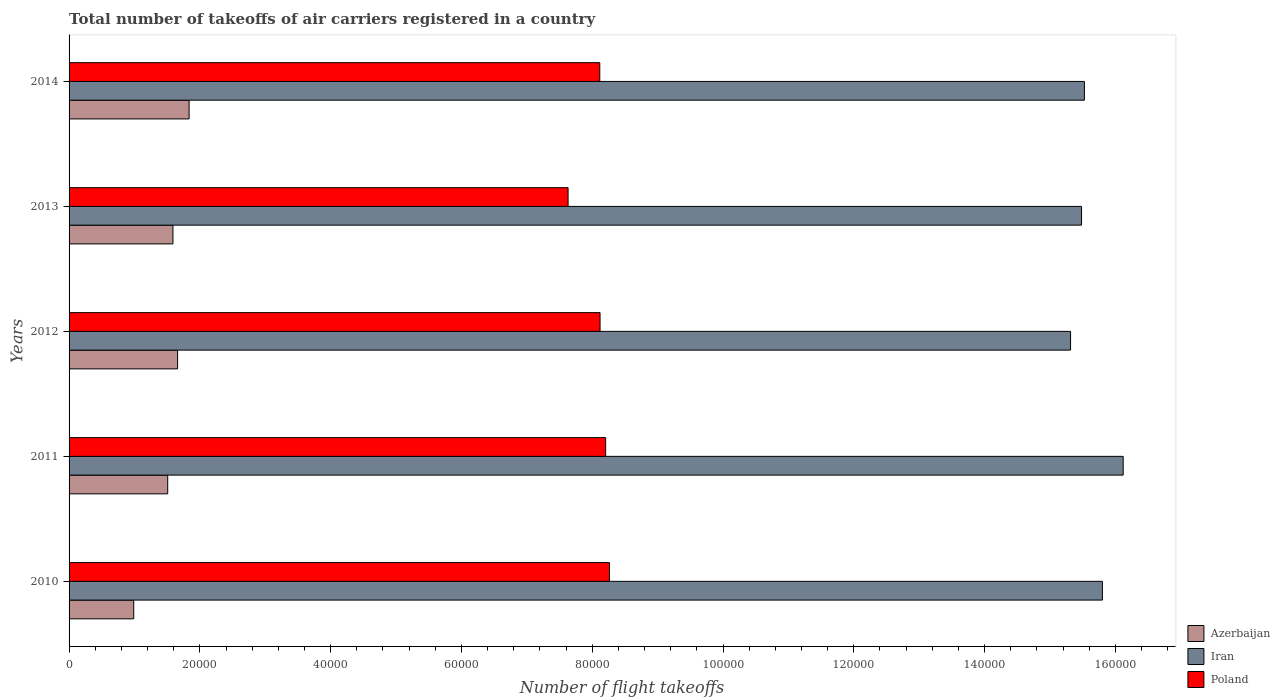In how many cases, is the number of bars for a given year not equal to the number of legend labels?
Offer a very short reply. 0. What is the total number of flight takeoffs in Iran in 2012?
Offer a very short reply. 1.53e+05. Across all years, what is the maximum total number of flight takeoffs in Iran?
Offer a terse response. 1.61e+05. Across all years, what is the minimum total number of flight takeoffs in Iran?
Ensure brevity in your answer.  1.53e+05. In which year was the total number of flight takeoffs in Iran maximum?
Give a very brief answer. 2011. What is the total total number of flight takeoffs in Poland in the graph?
Provide a short and direct response. 4.03e+05. What is the difference between the total number of flight takeoffs in Poland in 2010 and that in 2013?
Provide a short and direct response. 6324. What is the difference between the total number of flight takeoffs in Poland in 2010 and the total number of flight takeoffs in Iran in 2011?
Your answer should be compact. -7.86e+04. What is the average total number of flight takeoffs in Azerbaijan per year?
Offer a terse response. 1.52e+04. In the year 2011, what is the difference between the total number of flight takeoffs in Iran and total number of flight takeoffs in Azerbaijan?
Provide a short and direct response. 1.46e+05. In how many years, is the total number of flight takeoffs in Poland greater than 136000 ?
Ensure brevity in your answer.  0. What is the ratio of the total number of flight takeoffs in Azerbaijan in 2012 to that in 2013?
Your answer should be compact. 1.04. Is the difference between the total number of flight takeoffs in Iran in 2012 and 2013 greater than the difference between the total number of flight takeoffs in Azerbaijan in 2012 and 2013?
Ensure brevity in your answer.  No. What is the difference between the highest and the second highest total number of flight takeoffs in Poland?
Offer a very short reply. 578. What is the difference between the highest and the lowest total number of flight takeoffs in Iran?
Offer a terse response. 8048.86. In how many years, is the total number of flight takeoffs in Poland greater than the average total number of flight takeoffs in Poland taken over all years?
Your answer should be compact. 4. Is the sum of the total number of flight takeoffs in Poland in 2010 and 2012 greater than the maximum total number of flight takeoffs in Azerbaijan across all years?
Your response must be concise. Yes. What does the 3rd bar from the top in 2010 represents?
Give a very brief answer. Azerbaijan. What does the 2nd bar from the bottom in 2012 represents?
Provide a short and direct response. Iran. Is it the case that in every year, the sum of the total number of flight takeoffs in Azerbaijan and total number of flight takeoffs in Poland is greater than the total number of flight takeoffs in Iran?
Offer a very short reply. No. How many years are there in the graph?
Provide a succinct answer. 5. Are the values on the major ticks of X-axis written in scientific E-notation?
Provide a short and direct response. No. Does the graph contain any zero values?
Your answer should be compact. No. Where does the legend appear in the graph?
Your response must be concise. Bottom right. How are the legend labels stacked?
Make the answer very short. Vertical. What is the title of the graph?
Keep it short and to the point. Total number of takeoffs of air carriers registered in a country. Does "European Union" appear as one of the legend labels in the graph?
Offer a very short reply. No. What is the label or title of the X-axis?
Provide a succinct answer. Number of flight takeoffs. What is the label or title of the Y-axis?
Make the answer very short. Years. What is the Number of flight takeoffs of Azerbaijan in 2010?
Provide a succinct answer. 9885. What is the Number of flight takeoffs in Iran in 2010?
Your answer should be compact. 1.58e+05. What is the Number of flight takeoffs in Poland in 2010?
Provide a succinct answer. 8.26e+04. What is the Number of flight takeoffs of Azerbaijan in 2011?
Offer a very short reply. 1.51e+04. What is the Number of flight takeoffs of Iran in 2011?
Keep it short and to the point. 1.61e+05. What is the Number of flight takeoffs of Poland in 2011?
Provide a succinct answer. 8.21e+04. What is the Number of flight takeoffs in Azerbaijan in 2012?
Your answer should be very brief. 1.66e+04. What is the Number of flight takeoffs of Iran in 2012?
Offer a terse response. 1.53e+05. What is the Number of flight takeoffs in Poland in 2012?
Offer a terse response. 8.12e+04. What is the Number of flight takeoffs in Azerbaijan in 2013?
Make the answer very short. 1.59e+04. What is the Number of flight takeoffs in Iran in 2013?
Your answer should be very brief. 1.55e+05. What is the Number of flight takeoffs in Poland in 2013?
Your answer should be compact. 7.63e+04. What is the Number of flight takeoffs in Azerbaijan in 2014?
Make the answer very short. 1.84e+04. What is the Number of flight takeoffs of Iran in 2014?
Your answer should be compact. 1.55e+05. What is the Number of flight takeoffs of Poland in 2014?
Make the answer very short. 8.12e+04. Across all years, what is the maximum Number of flight takeoffs in Azerbaijan?
Your answer should be compact. 1.84e+04. Across all years, what is the maximum Number of flight takeoffs in Iran?
Your response must be concise. 1.61e+05. Across all years, what is the maximum Number of flight takeoffs of Poland?
Provide a succinct answer. 8.26e+04. Across all years, what is the minimum Number of flight takeoffs in Azerbaijan?
Give a very brief answer. 9885. Across all years, what is the minimum Number of flight takeoffs in Iran?
Offer a very short reply. 1.53e+05. Across all years, what is the minimum Number of flight takeoffs in Poland?
Keep it short and to the point. 7.63e+04. What is the total Number of flight takeoffs in Azerbaijan in the graph?
Provide a short and direct response. 7.58e+04. What is the total Number of flight takeoffs of Iran in the graph?
Offer a very short reply. 7.82e+05. What is the total Number of flight takeoffs of Poland in the graph?
Provide a succinct answer. 4.03e+05. What is the difference between the Number of flight takeoffs of Azerbaijan in 2010 and that in 2011?
Offer a very short reply. -5197. What is the difference between the Number of flight takeoffs in Iran in 2010 and that in 2011?
Your answer should be very brief. -3177.49. What is the difference between the Number of flight takeoffs of Poland in 2010 and that in 2011?
Make the answer very short. 578. What is the difference between the Number of flight takeoffs in Azerbaijan in 2010 and that in 2012?
Make the answer very short. -6712. What is the difference between the Number of flight takeoffs of Iran in 2010 and that in 2012?
Offer a very short reply. 4871.36. What is the difference between the Number of flight takeoffs in Poland in 2010 and that in 2012?
Offer a terse response. 1436. What is the difference between the Number of flight takeoffs of Azerbaijan in 2010 and that in 2013?
Ensure brevity in your answer.  -6001. What is the difference between the Number of flight takeoffs of Iran in 2010 and that in 2013?
Your answer should be very brief. 3192.8. What is the difference between the Number of flight takeoffs of Poland in 2010 and that in 2013?
Your answer should be very brief. 6324. What is the difference between the Number of flight takeoffs of Azerbaijan in 2010 and that in 2014?
Ensure brevity in your answer.  -8471. What is the difference between the Number of flight takeoffs of Iran in 2010 and that in 2014?
Make the answer very short. 2752.69. What is the difference between the Number of flight takeoffs in Poland in 2010 and that in 2014?
Your answer should be very brief. 1475.65. What is the difference between the Number of flight takeoffs of Azerbaijan in 2011 and that in 2012?
Your response must be concise. -1515. What is the difference between the Number of flight takeoffs in Iran in 2011 and that in 2012?
Offer a very short reply. 8048.86. What is the difference between the Number of flight takeoffs in Poland in 2011 and that in 2012?
Keep it short and to the point. 858. What is the difference between the Number of flight takeoffs in Azerbaijan in 2011 and that in 2013?
Keep it short and to the point. -804. What is the difference between the Number of flight takeoffs of Iran in 2011 and that in 2013?
Make the answer very short. 6370.29. What is the difference between the Number of flight takeoffs in Poland in 2011 and that in 2013?
Keep it short and to the point. 5746. What is the difference between the Number of flight takeoffs in Azerbaijan in 2011 and that in 2014?
Keep it short and to the point. -3274. What is the difference between the Number of flight takeoffs in Iran in 2011 and that in 2014?
Your answer should be very brief. 5930.18. What is the difference between the Number of flight takeoffs in Poland in 2011 and that in 2014?
Your answer should be compact. 897.65. What is the difference between the Number of flight takeoffs in Azerbaijan in 2012 and that in 2013?
Provide a short and direct response. 711. What is the difference between the Number of flight takeoffs of Iran in 2012 and that in 2013?
Keep it short and to the point. -1678.56. What is the difference between the Number of flight takeoffs in Poland in 2012 and that in 2013?
Offer a very short reply. 4888. What is the difference between the Number of flight takeoffs of Azerbaijan in 2012 and that in 2014?
Keep it short and to the point. -1759. What is the difference between the Number of flight takeoffs in Iran in 2012 and that in 2014?
Give a very brief answer. -2118.67. What is the difference between the Number of flight takeoffs in Poland in 2012 and that in 2014?
Your response must be concise. 39.65. What is the difference between the Number of flight takeoffs of Azerbaijan in 2013 and that in 2014?
Your answer should be compact. -2470. What is the difference between the Number of flight takeoffs of Iran in 2013 and that in 2014?
Provide a succinct answer. -440.11. What is the difference between the Number of flight takeoffs of Poland in 2013 and that in 2014?
Provide a succinct answer. -4848.35. What is the difference between the Number of flight takeoffs of Azerbaijan in 2010 and the Number of flight takeoffs of Iran in 2011?
Provide a succinct answer. -1.51e+05. What is the difference between the Number of flight takeoffs in Azerbaijan in 2010 and the Number of flight takeoffs in Poland in 2011?
Provide a succinct answer. -7.22e+04. What is the difference between the Number of flight takeoffs of Iran in 2010 and the Number of flight takeoffs of Poland in 2011?
Provide a succinct answer. 7.60e+04. What is the difference between the Number of flight takeoffs of Azerbaijan in 2010 and the Number of flight takeoffs of Iran in 2012?
Keep it short and to the point. -1.43e+05. What is the difference between the Number of flight takeoffs in Azerbaijan in 2010 and the Number of flight takeoffs in Poland in 2012?
Your response must be concise. -7.13e+04. What is the difference between the Number of flight takeoffs of Iran in 2010 and the Number of flight takeoffs of Poland in 2012?
Keep it short and to the point. 7.68e+04. What is the difference between the Number of flight takeoffs of Azerbaijan in 2010 and the Number of flight takeoffs of Iran in 2013?
Provide a succinct answer. -1.45e+05. What is the difference between the Number of flight takeoffs in Azerbaijan in 2010 and the Number of flight takeoffs in Poland in 2013?
Offer a terse response. -6.64e+04. What is the difference between the Number of flight takeoffs in Iran in 2010 and the Number of flight takeoffs in Poland in 2013?
Your response must be concise. 8.17e+04. What is the difference between the Number of flight takeoffs of Azerbaijan in 2010 and the Number of flight takeoffs of Iran in 2014?
Provide a succinct answer. -1.45e+05. What is the difference between the Number of flight takeoffs in Azerbaijan in 2010 and the Number of flight takeoffs in Poland in 2014?
Your answer should be compact. -7.13e+04. What is the difference between the Number of flight takeoffs of Iran in 2010 and the Number of flight takeoffs of Poland in 2014?
Ensure brevity in your answer.  7.69e+04. What is the difference between the Number of flight takeoffs in Azerbaijan in 2011 and the Number of flight takeoffs in Iran in 2012?
Ensure brevity in your answer.  -1.38e+05. What is the difference between the Number of flight takeoffs of Azerbaijan in 2011 and the Number of flight takeoffs of Poland in 2012?
Keep it short and to the point. -6.61e+04. What is the difference between the Number of flight takeoffs of Iran in 2011 and the Number of flight takeoffs of Poland in 2012?
Ensure brevity in your answer.  8.00e+04. What is the difference between the Number of flight takeoffs in Azerbaijan in 2011 and the Number of flight takeoffs in Iran in 2013?
Keep it short and to the point. -1.40e+05. What is the difference between the Number of flight takeoffs in Azerbaijan in 2011 and the Number of flight takeoffs in Poland in 2013?
Offer a very short reply. -6.12e+04. What is the difference between the Number of flight takeoffs of Iran in 2011 and the Number of flight takeoffs of Poland in 2013?
Keep it short and to the point. 8.49e+04. What is the difference between the Number of flight takeoffs in Azerbaijan in 2011 and the Number of flight takeoffs in Iran in 2014?
Offer a terse response. -1.40e+05. What is the difference between the Number of flight takeoffs of Azerbaijan in 2011 and the Number of flight takeoffs of Poland in 2014?
Your response must be concise. -6.61e+04. What is the difference between the Number of flight takeoffs of Iran in 2011 and the Number of flight takeoffs of Poland in 2014?
Provide a succinct answer. 8.00e+04. What is the difference between the Number of flight takeoffs of Azerbaijan in 2012 and the Number of flight takeoffs of Iran in 2013?
Your answer should be compact. -1.38e+05. What is the difference between the Number of flight takeoffs of Azerbaijan in 2012 and the Number of flight takeoffs of Poland in 2013?
Offer a terse response. -5.97e+04. What is the difference between the Number of flight takeoffs in Iran in 2012 and the Number of flight takeoffs in Poland in 2013?
Offer a terse response. 7.68e+04. What is the difference between the Number of flight takeoffs of Azerbaijan in 2012 and the Number of flight takeoffs of Iran in 2014?
Offer a very short reply. -1.39e+05. What is the difference between the Number of flight takeoffs in Azerbaijan in 2012 and the Number of flight takeoffs in Poland in 2014?
Your answer should be very brief. -6.46e+04. What is the difference between the Number of flight takeoffs in Iran in 2012 and the Number of flight takeoffs in Poland in 2014?
Ensure brevity in your answer.  7.20e+04. What is the difference between the Number of flight takeoffs of Azerbaijan in 2013 and the Number of flight takeoffs of Iran in 2014?
Give a very brief answer. -1.39e+05. What is the difference between the Number of flight takeoffs in Azerbaijan in 2013 and the Number of flight takeoffs in Poland in 2014?
Provide a short and direct response. -6.53e+04. What is the difference between the Number of flight takeoffs of Iran in 2013 and the Number of flight takeoffs of Poland in 2014?
Offer a terse response. 7.37e+04. What is the average Number of flight takeoffs of Azerbaijan per year?
Ensure brevity in your answer.  1.52e+04. What is the average Number of flight takeoffs in Iran per year?
Give a very brief answer. 1.56e+05. What is the average Number of flight takeoffs in Poland per year?
Provide a short and direct response. 8.07e+04. In the year 2010, what is the difference between the Number of flight takeoffs in Azerbaijan and Number of flight takeoffs in Iran?
Provide a short and direct response. -1.48e+05. In the year 2010, what is the difference between the Number of flight takeoffs of Azerbaijan and Number of flight takeoffs of Poland?
Your response must be concise. -7.27e+04. In the year 2010, what is the difference between the Number of flight takeoffs in Iran and Number of flight takeoffs in Poland?
Make the answer very short. 7.54e+04. In the year 2011, what is the difference between the Number of flight takeoffs of Azerbaijan and Number of flight takeoffs of Iran?
Offer a very short reply. -1.46e+05. In the year 2011, what is the difference between the Number of flight takeoffs in Azerbaijan and Number of flight takeoffs in Poland?
Offer a very short reply. -6.70e+04. In the year 2011, what is the difference between the Number of flight takeoffs of Iran and Number of flight takeoffs of Poland?
Provide a succinct answer. 7.91e+04. In the year 2012, what is the difference between the Number of flight takeoffs of Azerbaijan and Number of flight takeoffs of Iran?
Ensure brevity in your answer.  -1.37e+05. In the year 2012, what is the difference between the Number of flight takeoffs in Azerbaijan and Number of flight takeoffs in Poland?
Provide a short and direct response. -6.46e+04. In the year 2012, what is the difference between the Number of flight takeoffs of Iran and Number of flight takeoffs of Poland?
Your answer should be very brief. 7.19e+04. In the year 2013, what is the difference between the Number of flight takeoffs of Azerbaijan and Number of flight takeoffs of Iran?
Keep it short and to the point. -1.39e+05. In the year 2013, what is the difference between the Number of flight takeoffs in Azerbaijan and Number of flight takeoffs in Poland?
Your response must be concise. -6.04e+04. In the year 2013, what is the difference between the Number of flight takeoffs of Iran and Number of flight takeoffs of Poland?
Ensure brevity in your answer.  7.85e+04. In the year 2014, what is the difference between the Number of flight takeoffs in Azerbaijan and Number of flight takeoffs in Iran?
Ensure brevity in your answer.  -1.37e+05. In the year 2014, what is the difference between the Number of flight takeoffs of Azerbaijan and Number of flight takeoffs of Poland?
Your response must be concise. -6.28e+04. In the year 2014, what is the difference between the Number of flight takeoffs in Iran and Number of flight takeoffs in Poland?
Your response must be concise. 7.41e+04. What is the ratio of the Number of flight takeoffs of Azerbaijan in 2010 to that in 2011?
Make the answer very short. 0.66. What is the ratio of the Number of flight takeoffs of Iran in 2010 to that in 2011?
Ensure brevity in your answer.  0.98. What is the ratio of the Number of flight takeoffs of Azerbaijan in 2010 to that in 2012?
Your response must be concise. 0.6. What is the ratio of the Number of flight takeoffs in Iran in 2010 to that in 2012?
Your answer should be very brief. 1.03. What is the ratio of the Number of flight takeoffs of Poland in 2010 to that in 2012?
Keep it short and to the point. 1.02. What is the ratio of the Number of flight takeoffs in Azerbaijan in 2010 to that in 2013?
Provide a short and direct response. 0.62. What is the ratio of the Number of flight takeoffs in Iran in 2010 to that in 2013?
Your response must be concise. 1.02. What is the ratio of the Number of flight takeoffs in Poland in 2010 to that in 2013?
Offer a very short reply. 1.08. What is the ratio of the Number of flight takeoffs in Azerbaijan in 2010 to that in 2014?
Ensure brevity in your answer.  0.54. What is the ratio of the Number of flight takeoffs of Iran in 2010 to that in 2014?
Ensure brevity in your answer.  1.02. What is the ratio of the Number of flight takeoffs in Poland in 2010 to that in 2014?
Ensure brevity in your answer.  1.02. What is the ratio of the Number of flight takeoffs of Azerbaijan in 2011 to that in 2012?
Keep it short and to the point. 0.91. What is the ratio of the Number of flight takeoffs in Iran in 2011 to that in 2012?
Provide a succinct answer. 1.05. What is the ratio of the Number of flight takeoffs in Poland in 2011 to that in 2012?
Your answer should be compact. 1.01. What is the ratio of the Number of flight takeoffs in Azerbaijan in 2011 to that in 2013?
Your answer should be compact. 0.95. What is the ratio of the Number of flight takeoffs of Iran in 2011 to that in 2013?
Make the answer very short. 1.04. What is the ratio of the Number of flight takeoffs of Poland in 2011 to that in 2013?
Ensure brevity in your answer.  1.08. What is the ratio of the Number of flight takeoffs of Azerbaijan in 2011 to that in 2014?
Your response must be concise. 0.82. What is the ratio of the Number of flight takeoffs of Iran in 2011 to that in 2014?
Offer a terse response. 1.04. What is the ratio of the Number of flight takeoffs in Poland in 2011 to that in 2014?
Keep it short and to the point. 1.01. What is the ratio of the Number of flight takeoffs of Azerbaijan in 2012 to that in 2013?
Provide a short and direct response. 1.04. What is the ratio of the Number of flight takeoffs in Iran in 2012 to that in 2013?
Ensure brevity in your answer.  0.99. What is the ratio of the Number of flight takeoffs of Poland in 2012 to that in 2013?
Your response must be concise. 1.06. What is the ratio of the Number of flight takeoffs of Azerbaijan in 2012 to that in 2014?
Provide a short and direct response. 0.9. What is the ratio of the Number of flight takeoffs of Iran in 2012 to that in 2014?
Ensure brevity in your answer.  0.99. What is the ratio of the Number of flight takeoffs of Poland in 2012 to that in 2014?
Provide a short and direct response. 1. What is the ratio of the Number of flight takeoffs of Azerbaijan in 2013 to that in 2014?
Keep it short and to the point. 0.87. What is the ratio of the Number of flight takeoffs in Iran in 2013 to that in 2014?
Provide a short and direct response. 1. What is the ratio of the Number of flight takeoffs in Poland in 2013 to that in 2014?
Keep it short and to the point. 0.94. What is the difference between the highest and the second highest Number of flight takeoffs in Azerbaijan?
Provide a succinct answer. 1759. What is the difference between the highest and the second highest Number of flight takeoffs in Iran?
Offer a very short reply. 3177.49. What is the difference between the highest and the second highest Number of flight takeoffs of Poland?
Ensure brevity in your answer.  578. What is the difference between the highest and the lowest Number of flight takeoffs in Azerbaijan?
Give a very brief answer. 8471. What is the difference between the highest and the lowest Number of flight takeoffs in Iran?
Provide a succinct answer. 8048.86. What is the difference between the highest and the lowest Number of flight takeoffs of Poland?
Give a very brief answer. 6324. 